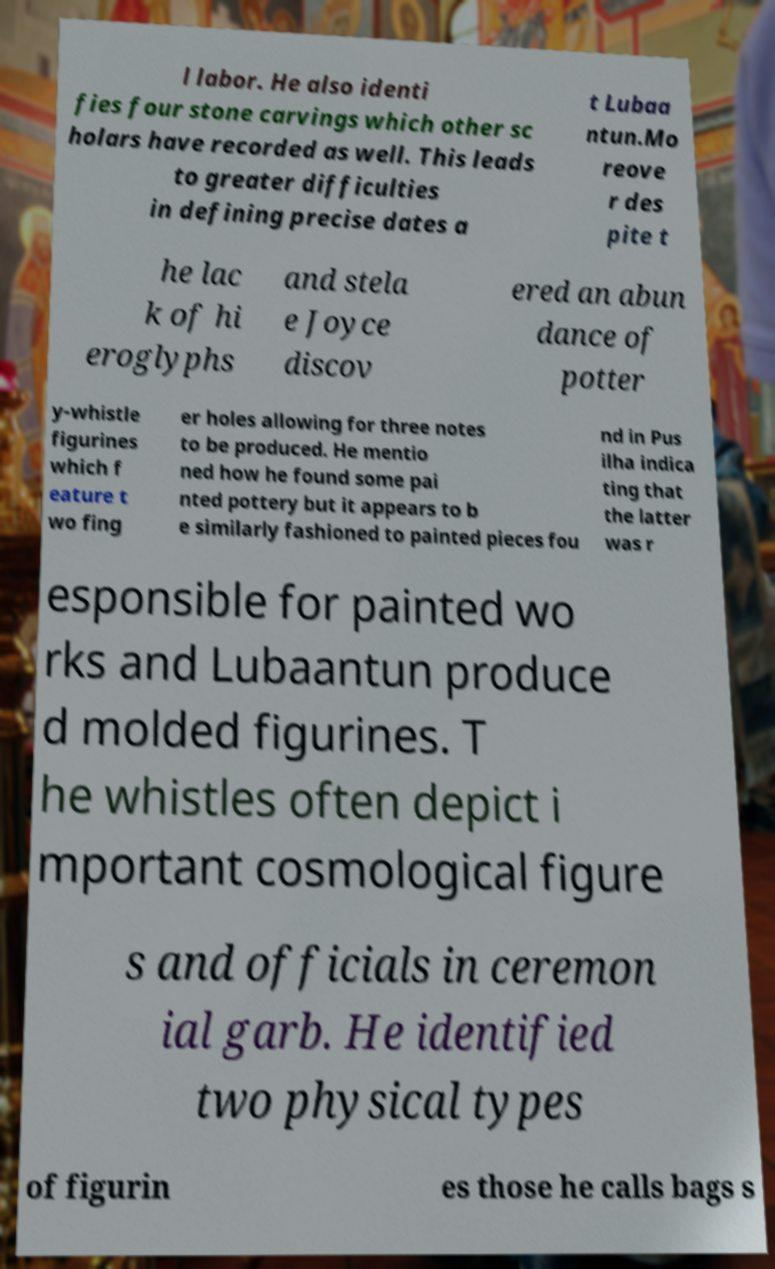Can you read and provide the text displayed in the image?This photo seems to have some interesting text. Can you extract and type it out for me? l labor. He also identi fies four stone carvings which other sc holars have recorded as well. This leads to greater difficulties in defining precise dates a t Lubaa ntun.Mo reove r des pite t he lac k of hi eroglyphs and stela e Joyce discov ered an abun dance of potter y-whistle figurines which f eature t wo fing er holes allowing for three notes to be produced. He mentio ned how he found some pai nted pottery but it appears to b e similarly fashioned to painted pieces fou nd in Pus ilha indica ting that the latter was r esponsible for painted wo rks and Lubaantun produce d molded figurines. T he whistles often depict i mportant cosmological figure s and officials in ceremon ial garb. He identified two physical types of figurin es those he calls bags s 